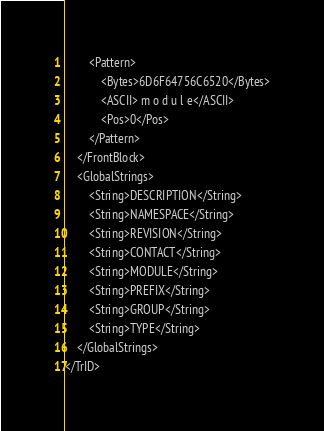<code> <loc_0><loc_0><loc_500><loc_500><_XML_>		<Pattern>
			<Bytes>6D6F64756C6520</Bytes>
			<ASCII> m o d u l e</ASCII>
			<Pos>0</Pos>
		</Pattern>
	</FrontBlock>
	<GlobalStrings>
		<String>DESCRIPTION</String>
		<String>NAMESPACE</String>
		<String>REVISION</String>
		<String>CONTACT</String>
		<String>MODULE</String>
		<String>PREFIX</String>
		<String>GROUP</String>
		<String>TYPE</String>
	</GlobalStrings>
</TrID></code> 